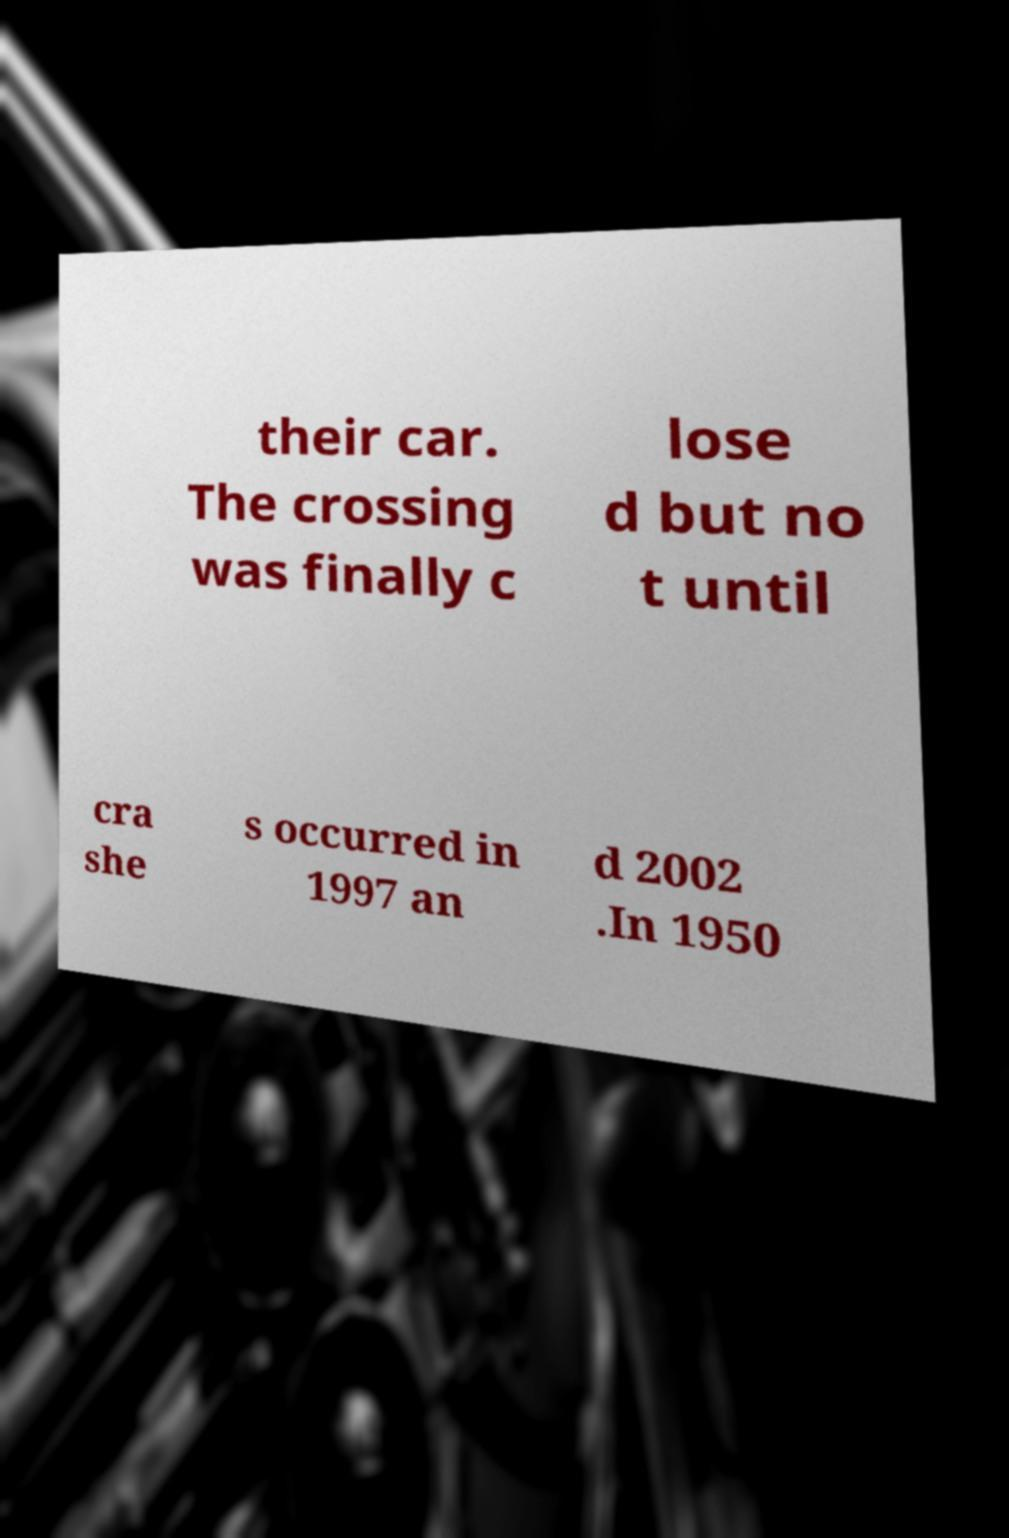Can you read and provide the text displayed in the image?This photo seems to have some interesting text. Can you extract and type it out for me? their car. The crossing was finally c lose d but no t until cra she s occurred in 1997 an d 2002 .In 1950 